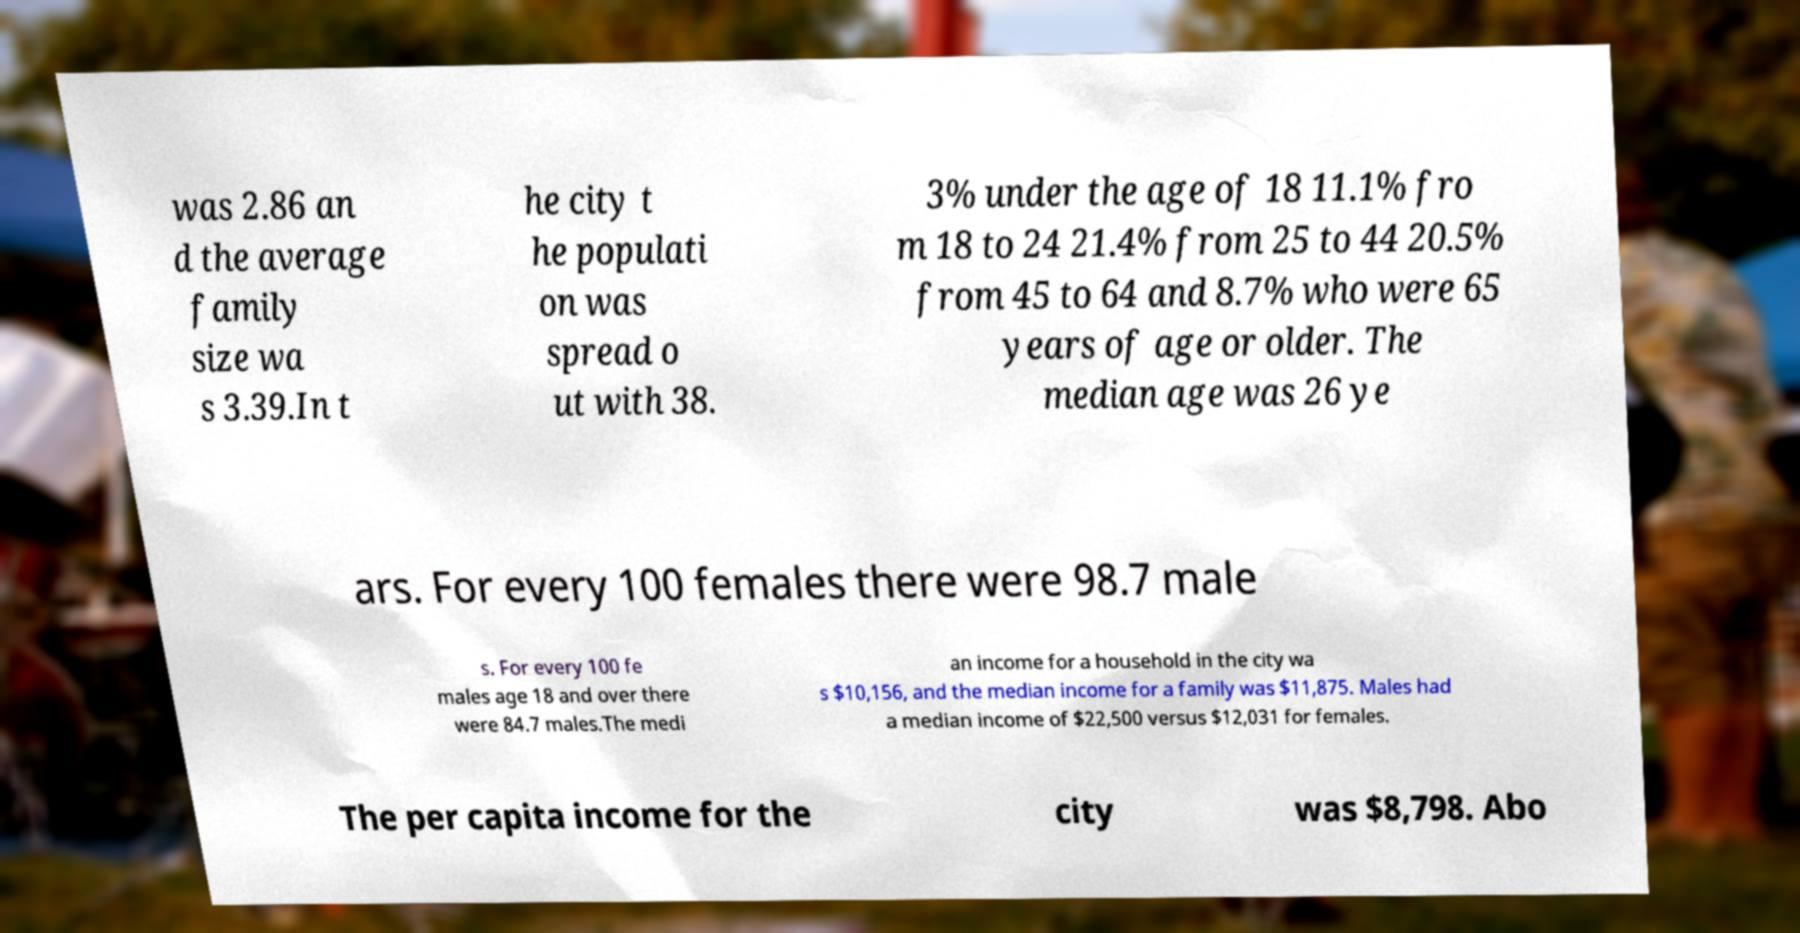What messages or text are displayed in this image? I need them in a readable, typed format. was 2.86 an d the average family size wa s 3.39.In t he city t he populati on was spread o ut with 38. 3% under the age of 18 11.1% fro m 18 to 24 21.4% from 25 to 44 20.5% from 45 to 64 and 8.7% who were 65 years of age or older. The median age was 26 ye ars. For every 100 females there were 98.7 male s. For every 100 fe males age 18 and over there were 84.7 males.The medi an income for a household in the city wa s $10,156, and the median income for a family was $11,875. Males had a median income of $22,500 versus $12,031 for females. The per capita income for the city was $8,798. Abo 